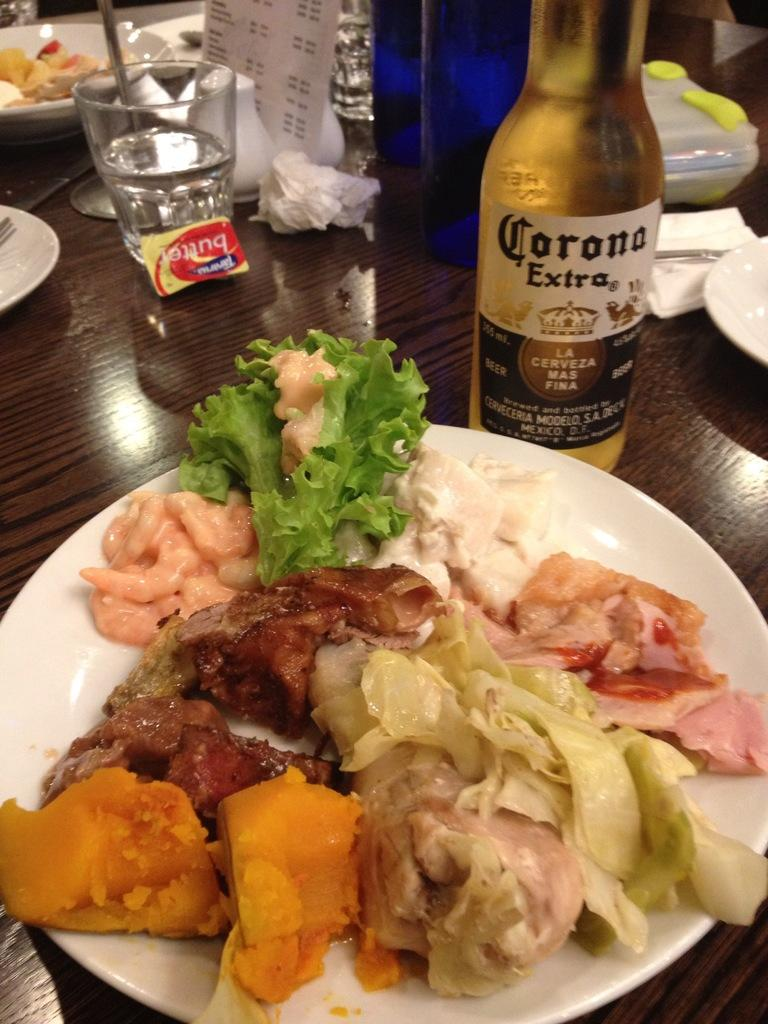<image>
Relay a brief, clear account of the picture shown. A plate full of food next to a bottle of Corona Extra. 